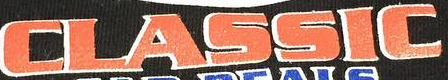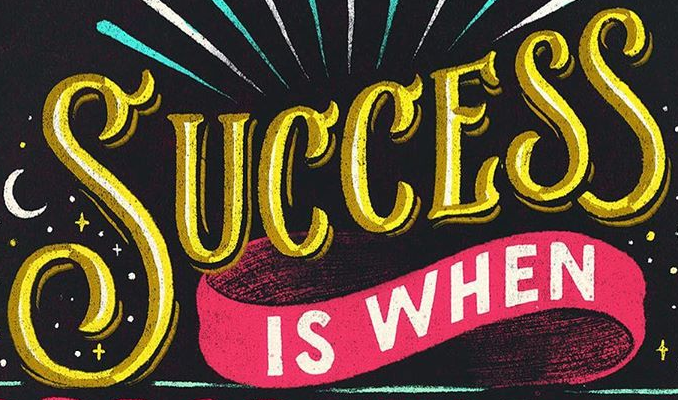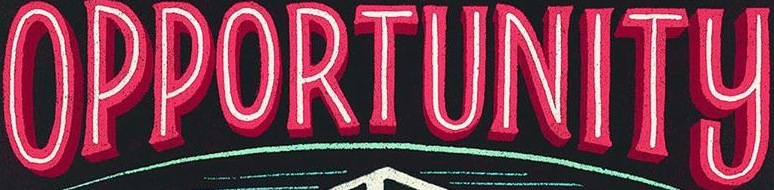Read the text content from these images in order, separated by a semicolon. CLASSIC; SUCCESS; OPPORTUNITY 